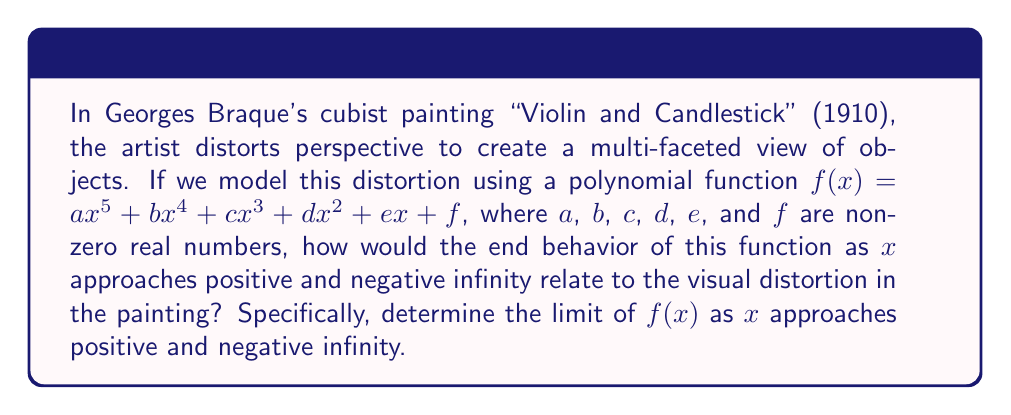Show me your answer to this math problem. To understand the end behavior of this higher-degree polynomial function and its relation to perspective distortion in Cubism, we need to analyze the limiting behavior of $f(x)$ as $x$ approaches positive and negative infinity.

1. The polynomial function is of degree 5, so the term with the highest degree ($ax^5$) will dominate the behavior as $x$ approaches infinity.

2. For very large positive or negative values of $x$, the lower-degree terms become insignificant compared to $ax^5$.

3. As $x$ approaches positive infinity:
   $\lim_{x \to +\infty} f(x) = \lim_{x \to +\infty} (ax^5 + bx^4 + cx^3 + dx^2 + ex + f) \approx \lim_{x \to +\infty} ax^5$

   If $a > 0$, then $\lim_{x \to +\infty} f(x) = +\infty$
   If $a < 0$, then $\lim_{x \to +\infty} f(x) = -\infty$

4. As $x$ approaches negative infinity:
   $\lim_{x \to -\infty} f(x) = \lim_{x \to -\infty} (ax^5 + bx^4 + cx^3 + dx^2 + ex + f) \approx \lim_{x \to -\infty} ax^5$

   If $a > 0$, then $\lim_{x \to -\infty} f(x) = -\infty$
   If $a < 0$, then $\lim_{x \to -\infty} f(x) = +\infty$

5. In the context of Cubism and Braque's work, this end behavior can be interpreted as the extreme distortion of perspective at the edges of the visual field. The rapid growth or decay of the function as $x$ approaches infinity represents the exaggerated warping of space in cubist paintings, where objects and planes seem to extend infinitely or collapse upon themselves at the periphery of the composition.
Answer: As $x$ approaches positive infinity: 
$\lim_{x \to +\infty} f(x) = \begin{cases} +\infty & \text{if } a > 0 \\ -\infty & \text{if } a < 0 \end{cases}$

As $x$ approaches negative infinity:
$\lim_{x \to -\infty} f(x) = \begin{cases} -\infty & \text{if } a > 0 \\ +\infty & \text{if } a < 0 \end{cases}$ 